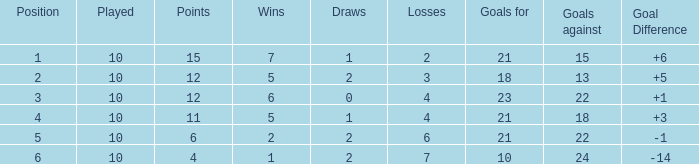Can you inform me of the total wins with more than 0 draws and having 11 points? 1.0. 